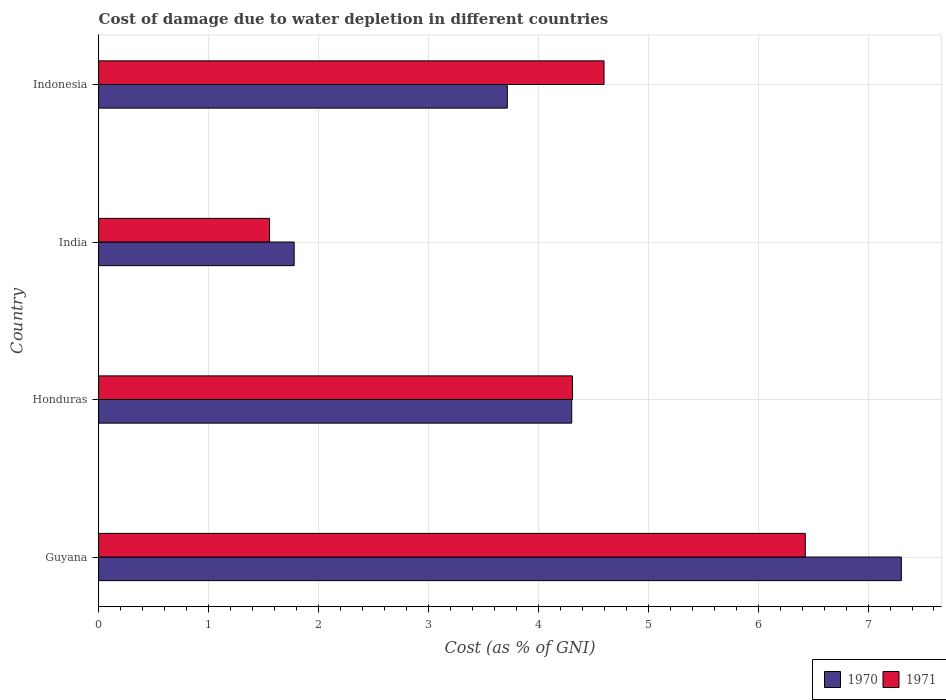Are the number of bars per tick equal to the number of legend labels?
Your answer should be compact. Yes. Are the number of bars on each tick of the Y-axis equal?
Offer a terse response. Yes. What is the label of the 3rd group of bars from the top?
Keep it short and to the point. Honduras. In how many cases, is the number of bars for a given country not equal to the number of legend labels?
Make the answer very short. 0. What is the cost of damage caused due to water depletion in 1970 in Indonesia?
Offer a terse response. 3.72. Across all countries, what is the maximum cost of damage caused due to water depletion in 1971?
Offer a terse response. 6.43. Across all countries, what is the minimum cost of damage caused due to water depletion in 1970?
Make the answer very short. 1.78. In which country was the cost of damage caused due to water depletion in 1970 maximum?
Keep it short and to the point. Guyana. What is the total cost of damage caused due to water depletion in 1970 in the graph?
Provide a succinct answer. 17.1. What is the difference between the cost of damage caused due to water depletion in 1970 in Honduras and that in India?
Provide a short and direct response. 2.53. What is the difference between the cost of damage caused due to water depletion in 1971 in Honduras and the cost of damage caused due to water depletion in 1970 in Guyana?
Your response must be concise. -2.99. What is the average cost of damage caused due to water depletion in 1970 per country?
Make the answer very short. 4.28. What is the difference between the cost of damage caused due to water depletion in 1970 and cost of damage caused due to water depletion in 1971 in Indonesia?
Keep it short and to the point. -0.88. In how many countries, is the cost of damage caused due to water depletion in 1970 greater than 0.2 %?
Offer a terse response. 4. What is the ratio of the cost of damage caused due to water depletion in 1971 in India to that in Indonesia?
Provide a short and direct response. 0.34. Is the cost of damage caused due to water depletion in 1970 in Honduras less than that in India?
Make the answer very short. No. Is the difference between the cost of damage caused due to water depletion in 1970 in Guyana and Honduras greater than the difference between the cost of damage caused due to water depletion in 1971 in Guyana and Honduras?
Keep it short and to the point. Yes. What is the difference between the highest and the second highest cost of damage caused due to water depletion in 1971?
Ensure brevity in your answer.  1.83. What is the difference between the highest and the lowest cost of damage caused due to water depletion in 1970?
Your response must be concise. 5.52. In how many countries, is the cost of damage caused due to water depletion in 1971 greater than the average cost of damage caused due to water depletion in 1971 taken over all countries?
Your answer should be very brief. 3. Is the sum of the cost of damage caused due to water depletion in 1970 in Guyana and Honduras greater than the maximum cost of damage caused due to water depletion in 1971 across all countries?
Your response must be concise. Yes. How many countries are there in the graph?
Offer a very short reply. 4. What is the difference between two consecutive major ticks on the X-axis?
Your answer should be compact. 1. Are the values on the major ticks of X-axis written in scientific E-notation?
Ensure brevity in your answer.  No. Does the graph contain any zero values?
Your answer should be compact. No. How are the legend labels stacked?
Your answer should be compact. Horizontal. What is the title of the graph?
Your response must be concise. Cost of damage due to water depletion in different countries. What is the label or title of the X-axis?
Offer a terse response. Cost (as % of GNI). What is the label or title of the Y-axis?
Offer a very short reply. Country. What is the Cost (as % of GNI) in 1970 in Guyana?
Keep it short and to the point. 7.3. What is the Cost (as % of GNI) in 1971 in Guyana?
Ensure brevity in your answer.  6.43. What is the Cost (as % of GNI) in 1970 in Honduras?
Your answer should be compact. 4.3. What is the Cost (as % of GNI) in 1971 in Honduras?
Offer a terse response. 4.31. What is the Cost (as % of GNI) of 1970 in India?
Your answer should be very brief. 1.78. What is the Cost (as % of GNI) in 1971 in India?
Your answer should be compact. 1.55. What is the Cost (as % of GNI) in 1970 in Indonesia?
Your answer should be very brief. 3.72. What is the Cost (as % of GNI) in 1971 in Indonesia?
Provide a succinct answer. 4.6. Across all countries, what is the maximum Cost (as % of GNI) of 1970?
Provide a short and direct response. 7.3. Across all countries, what is the maximum Cost (as % of GNI) of 1971?
Give a very brief answer. 6.43. Across all countries, what is the minimum Cost (as % of GNI) of 1970?
Give a very brief answer. 1.78. Across all countries, what is the minimum Cost (as % of GNI) of 1971?
Provide a short and direct response. 1.55. What is the total Cost (as % of GNI) of 1970 in the graph?
Offer a very short reply. 17.1. What is the total Cost (as % of GNI) in 1971 in the graph?
Ensure brevity in your answer.  16.89. What is the difference between the Cost (as % of GNI) in 1970 in Guyana and that in Honduras?
Your answer should be compact. 3. What is the difference between the Cost (as % of GNI) in 1971 in Guyana and that in Honduras?
Offer a very short reply. 2.12. What is the difference between the Cost (as % of GNI) of 1970 in Guyana and that in India?
Provide a short and direct response. 5.52. What is the difference between the Cost (as % of GNI) of 1971 in Guyana and that in India?
Provide a succinct answer. 4.87. What is the difference between the Cost (as % of GNI) of 1970 in Guyana and that in Indonesia?
Make the answer very short. 3.58. What is the difference between the Cost (as % of GNI) of 1971 in Guyana and that in Indonesia?
Ensure brevity in your answer.  1.83. What is the difference between the Cost (as % of GNI) in 1970 in Honduras and that in India?
Make the answer very short. 2.53. What is the difference between the Cost (as % of GNI) of 1971 in Honduras and that in India?
Your answer should be compact. 2.76. What is the difference between the Cost (as % of GNI) of 1970 in Honduras and that in Indonesia?
Make the answer very short. 0.59. What is the difference between the Cost (as % of GNI) of 1971 in Honduras and that in Indonesia?
Ensure brevity in your answer.  -0.29. What is the difference between the Cost (as % of GNI) of 1970 in India and that in Indonesia?
Ensure brevity in your answer.  -1.94. What is the difference between the Cost (as % of GNI) in 1971 in India and that in Indonesia?
Offer a terse response. -3.04. What is the difference between the Cost (as % of GNI) of 1970 in Guyana and the Cost (as % of GNI) of 1971 in Honduras?
Offer a terse response. 2.99. What is the difference between the Cost (as % of GNI) of 1970 in Guyana and the Cost (as % of GNI) of 1971 in India?
Offer a terse response. 5.75. What is the difference between the Cost (as % of GNI) of 1970 in Guyana and the Cost (as % of GNI) of 1971 in Indonesia?
Provide a succinct answer. 2.71. What is the difference between the Cost (as % of GNI) of 1970 in Honduras and the Cost (as % of GNI) of 1971 in India?
Give a very brief answer. 2.75. What is the difference between the Cost (as % of GNI) of 1970 in Honduras and the Cost (as % of GNI) of 1971 in Indonesia?
Provide a succinct answer. -0.29. What is the difference between the Cost (as % of GNI) of 1970 in India and the Cost (as % of GNI) of 1971 in Indonesia?
Provide a short and direct response. -2.82. What is the average Cost (as % of GNI) of 1970 per country?
Provide a succinct answer. 4.28. What is the average Cost (as % of GNI) in 1971 per country?
Make the answer very short. 4.22. What is the difference between the Cost (as % of GNI) in 1970 and Cost (as % of GNI) in 1971 in Guyana?
Provide a succinct answer. 0.87. What is the difference between the Cost (as % of GNI) of 1970 and Cost (as % of GNI) of 1971 in Honduras?
Your answer should be very brief. -0.01. What is the difference between the Cost (as % of GNI) in 1970 and Cost (as % of GNI) in 1971 in India?
Your answer should be very brief. 0.22. What is the difference between the Cost (as % of GNI) of 1970 and Cost (as % of GNI) of 1971 in Indonesia?
Your response must be concise. -0.88. What is the ratio of the Cost (as % of GNI) in 1970 in Guyana to that in Honduras?
Your response must be concise. 1.7. What is the ratio of the Cost (as % of GNI) of 1971 in Guyana to that in Honduras?
Provide a short and direct response. 1.49. What is the ratio of the Cost (as % of GNI) in 1970 in Guyana to that in India?
Make the answer very short. 4.11. What is the ratio of the Cost (as % of GNI) of 1971 in Guyana to that in India?
Provide a succinct answer. 4.13. What is the ratio of the Cost (as % of GNI) in 1970 in Guyana to that in Indonesia?
Ensure brevity in your answer.  1.96. What is the ratio of the Cost (as % of GNI) of 1971 in Guyana to that in Indonesia?
Keep it short and to the point. 1.4. What is the ratio of the Cost (as % of GNI) in 1970 in Honduras to that in India?
Offer a very short reply. 2.42. What is the ratio of the Cost (as % of GNI) of 1971 in Honduras to that in India?
Offer a terse response. 2.77. What is the ratio of the Cost (as % of GNI) in 1970 in Honduras to that in Indonesia?
Keep it short and to the point. 1.16. What is the ratio of the Cost (as % of GNI) in 1970 in India to that in Indonesia?
Your answer should be compact. 0.48. What is the ratio of the Cost (as % of GNI) in 1971 in India to that in Indonesia?
Make the answer very short. 0.34. What is the difference between the highest and the second highest Cost (as % of GNI) of 1970?
Keep it short and to the point. 3. What is the difference between the highest and the second highest Cost (as % of GNI) of 1971?
Offer a terse response. 1.83. What is the difference between the highest and the lowest Cost (as % of GNI) of 1970?
Your response must be concise. 5.52. What is the difference between the highest and the lowest Cost (as % of GNI) of 1971?
Provide a short and direct response. 4.87. 